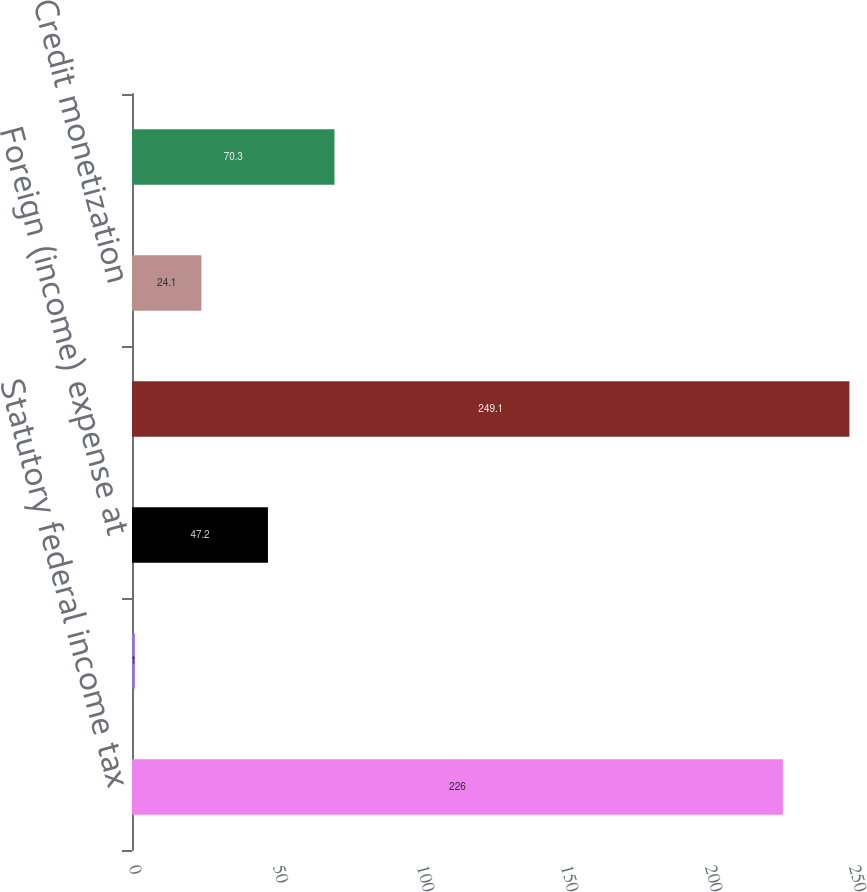Convert chart. <chart><loc_0><loc_0><loc_500><loc_500><bar_chart><fcel>Statutory federal income tax<fcel>State taxes net of federal<fcel>Foreign (income) expense at<fcel>US valuation allowance<fcel>Credit monetization<fcel>Provision for income taxes<nl><fcel>226<fcel>1<fcel>47.2<fcel>249.1<fcel>24.1<fcel>70.3<nl></chart> 